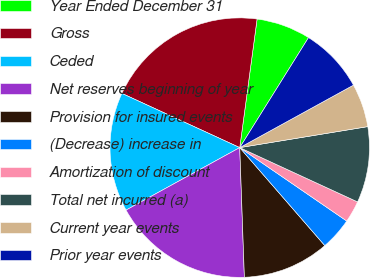Convert chart. <chart><loc_0><loc_0><loc_500><loc_500><pie_chart><fcel>Year Ended December 31<fcel>Gross<fcel>Ceded<fcel>Net reserves beginning of year<fcel>Provision for insured events<fcel>(Decrease) increase in<fcel>Amortization of discount<fcel>Total net incurred (a)<fcel>Current year events<fcel>Prior year events<nl><fcel>6.76%<fcel>20.27%<fcel>14.86%<fcel>17.57%<fcel>10.81%<fcel>4.05%<fcel>2.7%<fcel>9.46%<fcel>5.41%<fcel>8.11%<nl></chart> 